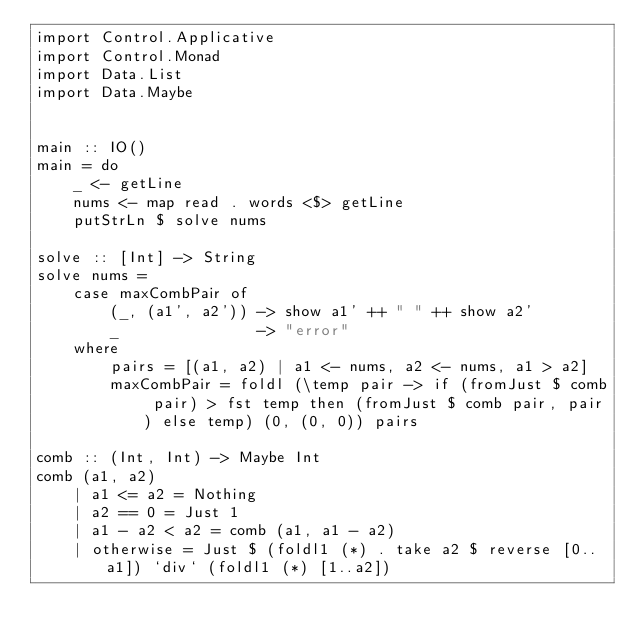<code> <loc_0><loc_0><loc_500><loc_500><_Haskell_>import Control.Applicative
import Control.Monad
import Data.List
import Data.Maybe


main :: IO()
main = do
    _ <- getLine
    nums <- map read . words <$> getLine
    putStrLn $ solve nums

solve :: [Int] -> String
solve nums =
    case maxCombPair of
        (_, (a1', a2')) -> show a1' ++ " " ++ show a2'
        _               -> "error"
    where
        pairs = [(a1, a2) | a1 <- nums, a2 <- nums, a1 > a2]
        maxCombPair = foldl (\temp pair -> if (fromJust $ comb pair) > fst temp then (fromJust $ comb pair, pair) else temp) (0, (0, 0)) pairs

comb :: (Int, Int) -> Maybe Int
comb (a1, a2)
    | a1 <= a2 = Nothing
    | a2 == 0 = Just 1
    | a1 - a2 < a2 = comb (a1, a1 - a2)
    | otherwise = Just $ (foldl1 (*) . take a2 $ reverse [0..a1]) `div` (foldl1 (*) [1..a2])</code> 